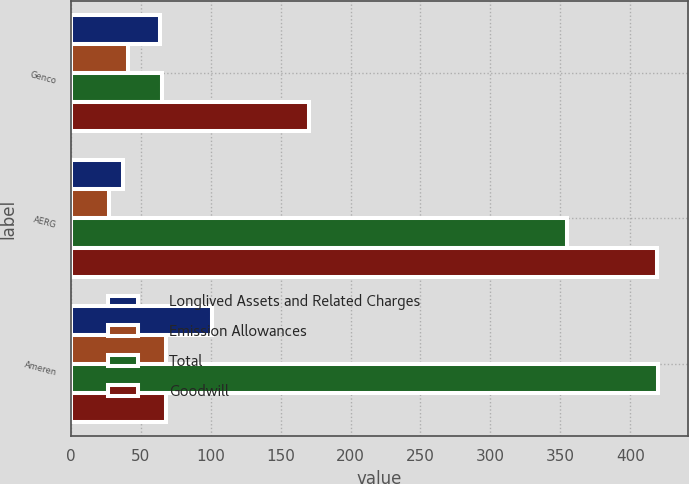Convert chart to OTSL. <chart><loc_0><loc_0><loc_500><loc_500><stacked_bar_chart><ecel><fcel>Genco<fcel>AERG<fcel>Ameren<nl><fcel>Longlived Assets and Related Charges<fcel>64<fcel>37<fcel>101<nl><fcel>Emission Allowances<fcel>41<fcel>27<fcel>68<nl><fcel>Total<fcel>65<fcel>355<fcel>420<nl><fcel>Goodwill<fcel>170<fcel>419<fcel>68<nl></chart> 